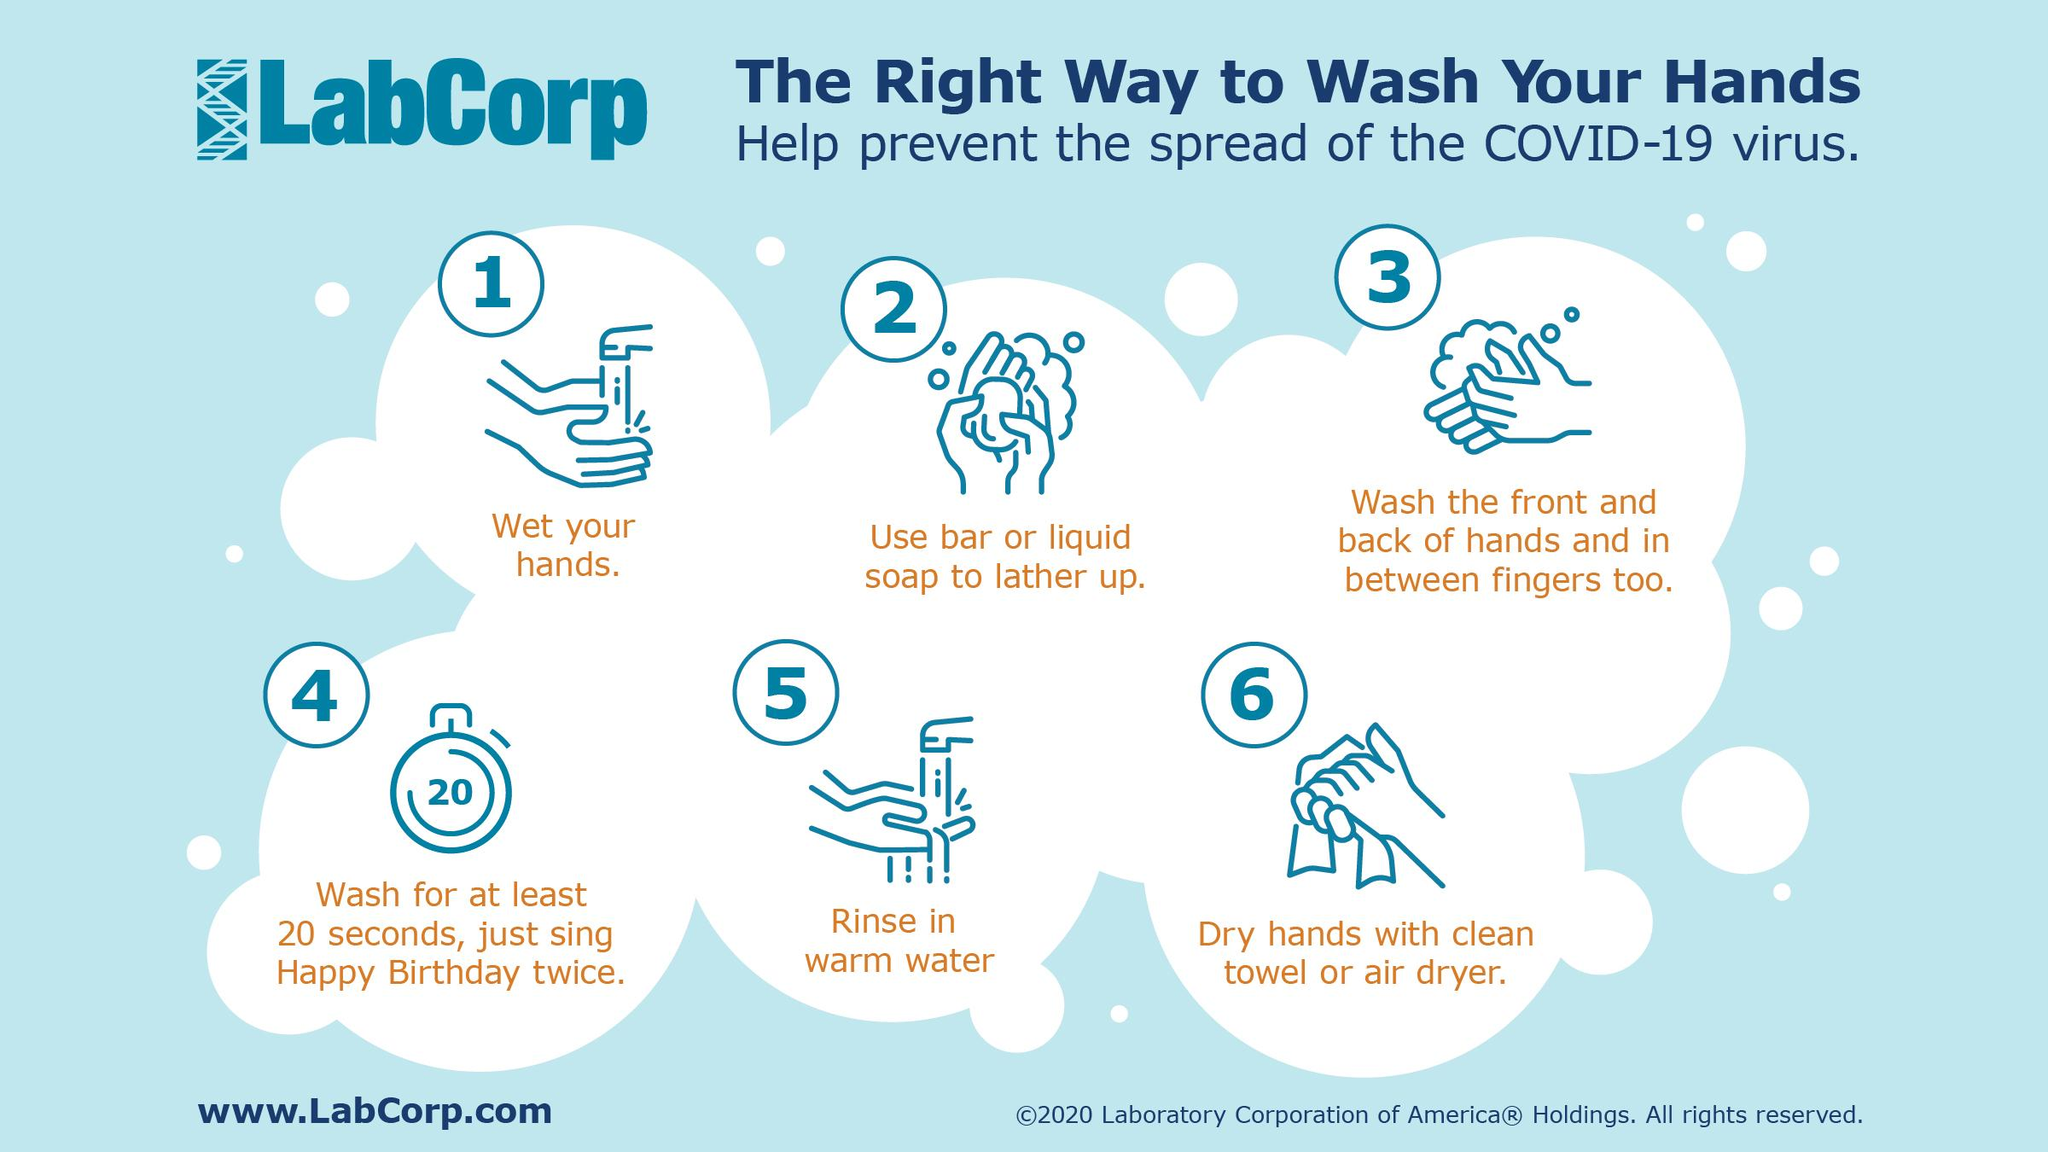Draw attention to some important aspects in this diagram. Hand washing with water is demonstrated in 2 steps. The video demonstrates how to dry your hands using a clean towel or an air dryer in step 6. It is recommended that the hands be washed for a minimum of 20 seconds in order to effectively prevent the spread of the Covid-19 virus. 